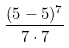Convert formula to latex. <formula><loc_0><loc_0><loc_500><loc_500>\frac { ( 5 - 5 ) ^ { 7 } } { 7 \cdot 7 }</formula> 